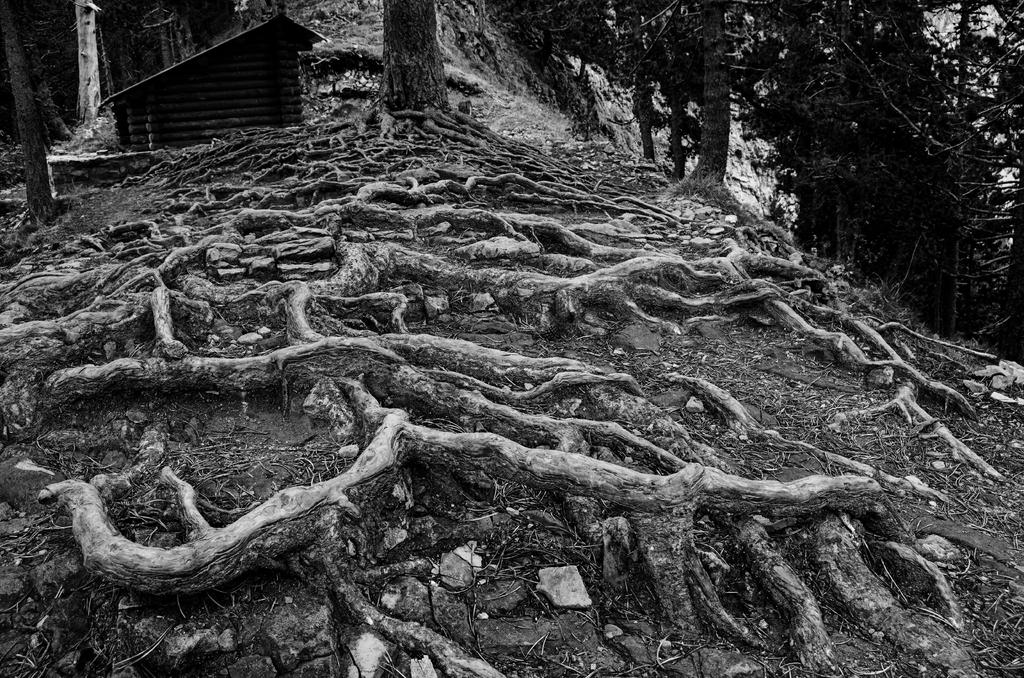What natural elements can be seen in the image? The image contains tree roots. What structure is located on the left side of the image? There is a shed on the left side of the image. What type of vegetation is on the right side of the image? There are trees on the right side of the image. What type of cloth is being used for the voyage in the image? There is no voyage or cloth present in the image. How does the digestion process of the tree roots appear in the image? The image does not show the digestion process of the tree roots; it only displays the visible tree roots. 